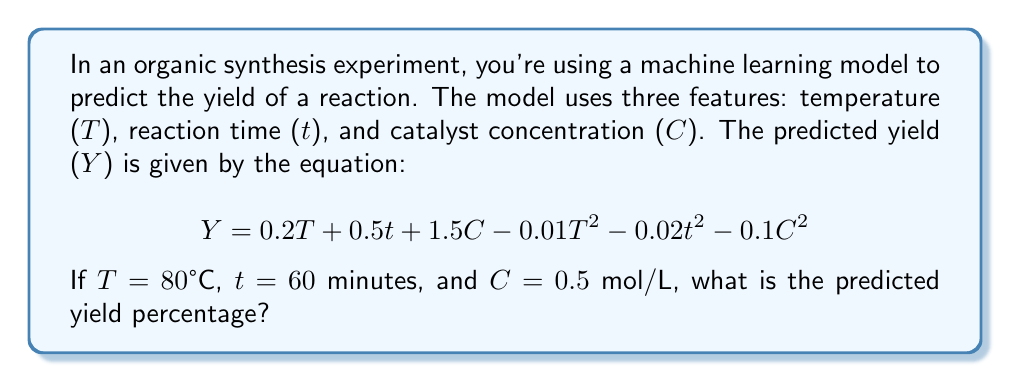Can you solve this math problem? To solve this problem, we'll follow these steps:

1) We have the equation for the predicted yield (Y):
   $$ Y = 0.2T + 0.5t + 1.5C - 0.01T^2 - 0.02t^2 - 0.1C^2 $$

2) We're given the values:
   T = 80°C
   t = 60 minutes
   C = 0.5 mol/L

3) Let's substitute these values into the equation:
   $$ Y = 0.2(80) + 0.5(60) + 1.5(0.5) - 0.01(80)^2 - 0.02(60)^2 - 0.1(0.5)^2 $$

4) Now, let's calculate each term:
   $0.2(80) = 16$
   $0.5(60) = 30$
   $1.5(0.5) = 0.75$
   $0.01(80)^2 = 0.01(6400) = 64$
   $0.02(60)^2 = 0.02(3600) = 72$
   $0.1(0.5)^2 = 0.1(0.25) = 0.025$

5) Substituting these values:
   $$ Y = 16 + 30 + 0.75 - 64 - 72 - 0.025 $$

6) Adding and subtracting:
   $$ Y = 46.75 - 136.025 = -89.275 $$

7) Since yield is typically expressed as a percentage, we'll round to two decimal places:
   $$ Y \approx -89.28\% $$

8) However, in real-world scenarios, yield cannot be negative. This negative result suggests that the model is predicting that the reaction won't proceed under these conditions, or that the model needs refinement for these input values.
Answer: -89.28% (indicating model limitations for given conditions) 